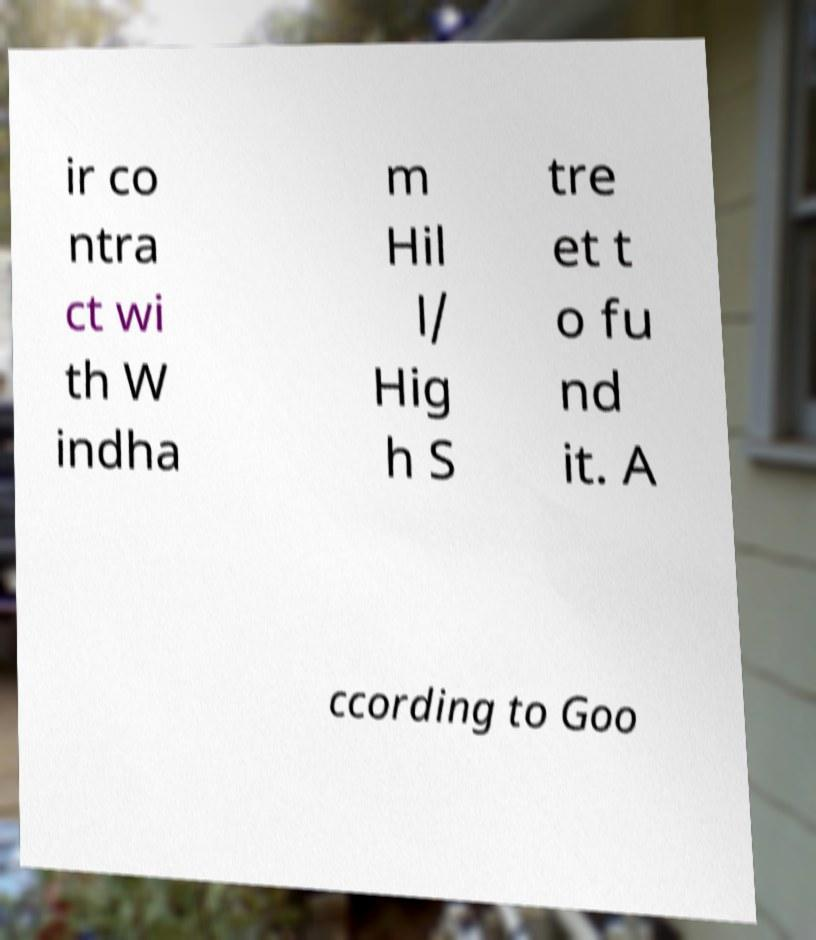Please identify and transcribe the text found in this image. ir co ntra ct wi th W indha m Hil l/ Hig h S tre et t o fu nd it. A ccording to Goo 